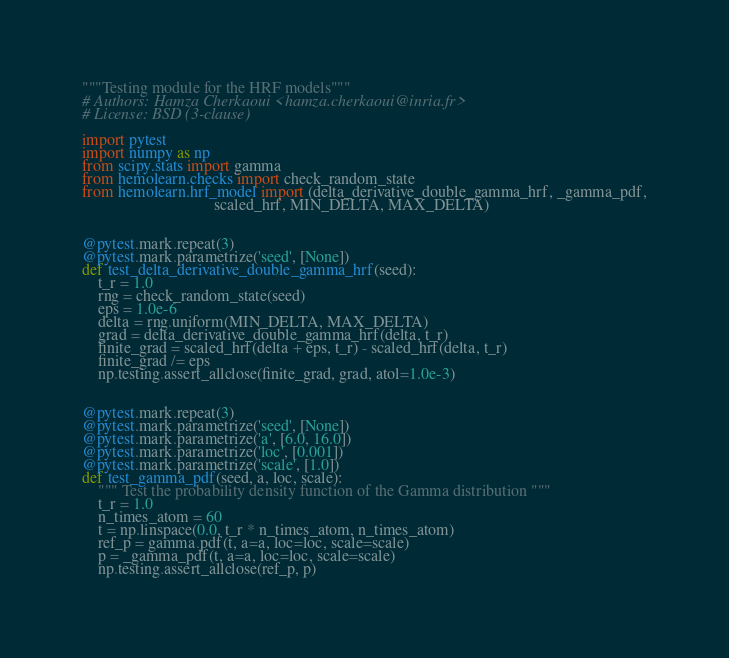<code> <loc_0><loc_0><loc_500><loc_500><_Python_>"""Testing module for the HRF models"""
# Authors: Hamza Cherkaoui <hamza.cherkaoui@inria.fr>
# License: BSD (3-clause)

import pytest
import numpy as np
from scipy.stats import gamma
from hemolearn.checks import check_random_state
from hemolearn.hrf_model import (delta_derivative_double_gamma_hrf, _gamma_pdf,
                                 scaled_hrf, MIN_DELTA, MAX_DELTA)


@pytest.mark.repeat(3)
@pytest.mark.parametrize('seed', [None])
def test_delta_derivative_double_gamma_hrf(seed):
    t_r = 1.0
    rng = check_random_state(seed)
    eps = 1.0e-6
    delta = rng.uniform(MIN_DELTA, MAX_DELTA)
    grad = delta_derivative_double_gamma_hrf(delta, t_r)
    finite_grad = scaled_hrf(delta + eps, t_r) - scaled_hrf(delta, t_r)
    finite_grad /= eps
    np.testing.assert_allclose(finite_grad, grad, atol=1.0e-3)


@pytest.mark.repeat(3)
@pytest.mark.parametrize('seed', [None])
@pytest.mark.parametrize('a', [6.0, 16.0])
@pytest.mark.parametrize('loc', [0.001])
@pytest.mark.parametrize('scale', [1.0])
def test_gamma_pdf(seed, a, loc, scale):
    """ Test the probability density function of the Gamma distribution """
    t_r = 1.0
    n_times_atom = 60
    t = np.linspace(0.0, t_r * n_times_atom, n_times_atom)
    ref_p = gamma.pdf(t, a=a, loc=loc, scale=scale)
    p = _gamma_pdf(t, a=a, loc=loc, scale=scale)
    np.testing.assert_allclose(ref_p, p)
</code> 